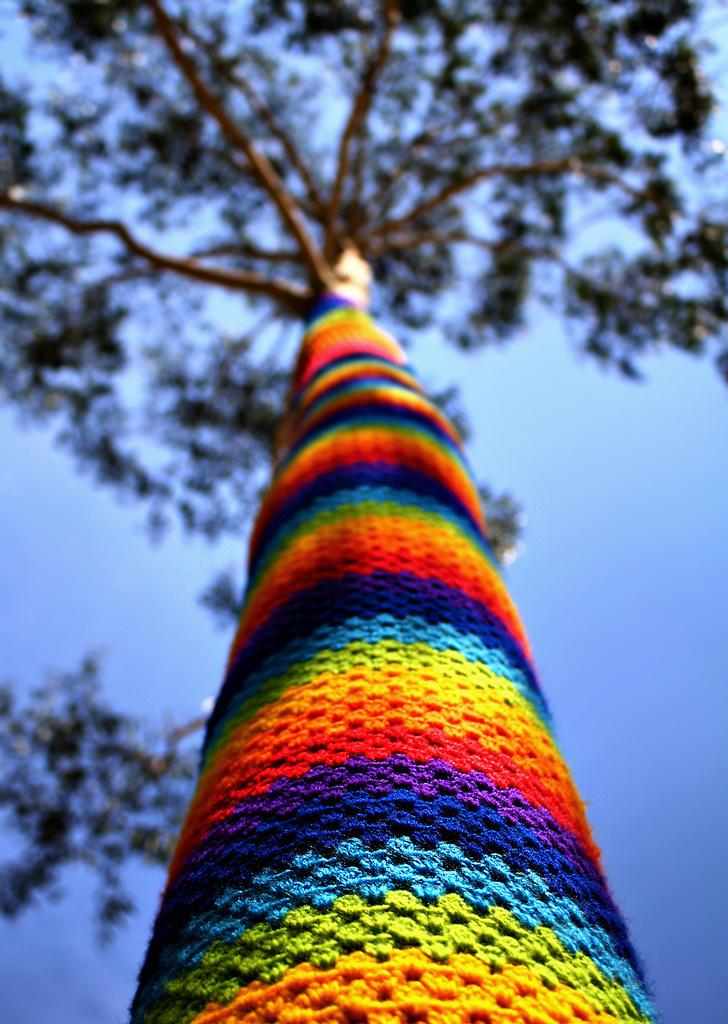What is the main object in the image? There is a tree in the image. What is attached to the tree? Colorful cloth is attached to the bark of the tree. What type of competition is taking place near the tree in the image? There is no competition present in the image; it only features a tree with colorful cloth attached to its bark. 